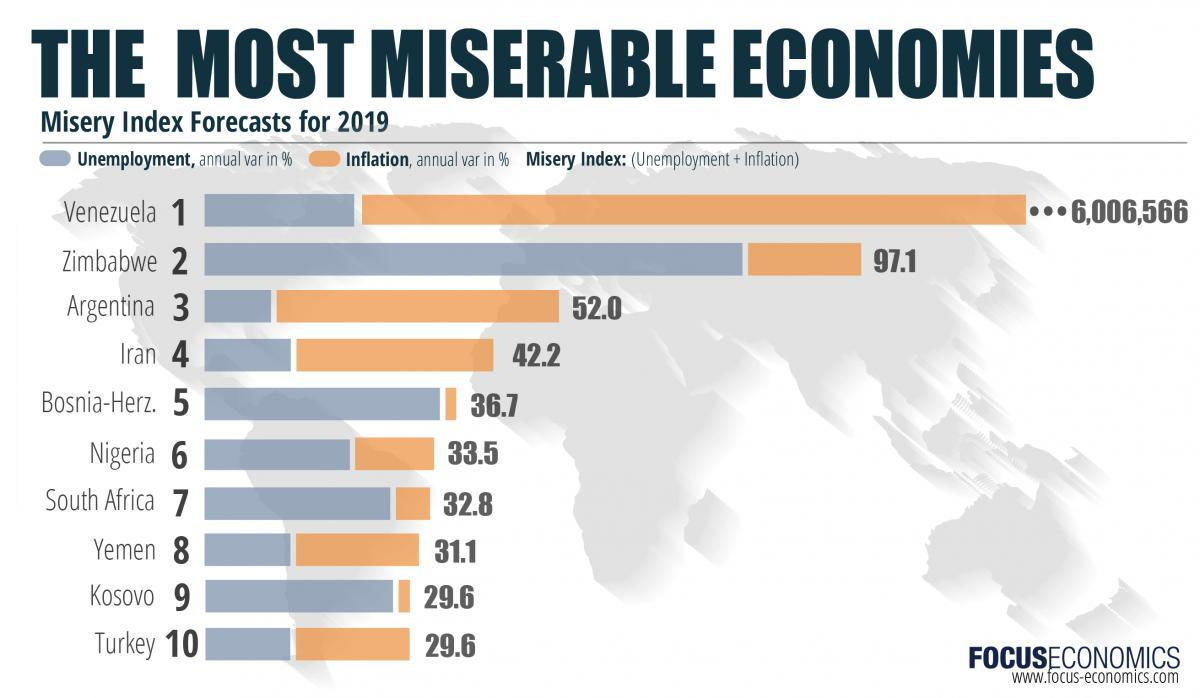What is the misery index of Yemen according to the the Misery Index Forecasts for 2019?
Answer the question with a short phrase. 31.1 Which country has the highest annual var percentage of inflation as per the Misery Index Forecasts for 2019? Venezuela Which country has the second highest annual var percentage of inflation as per the Misery Index Forecasts for 2019? Argentina Which country shows the highest misery index according to the the Misery Index Forecasts for 2019? Venezuela Which country has the least annual var percentage of unemployment as per the Misery Index Forecasts for 2019? Argentina Which country has the highest annual var percentage of unemployment as per the Misery Index Forecasts for 2019? Zimbabwe What is the misery index of Iran according to the the Misery Index Forecasts for 2019? 42.2 